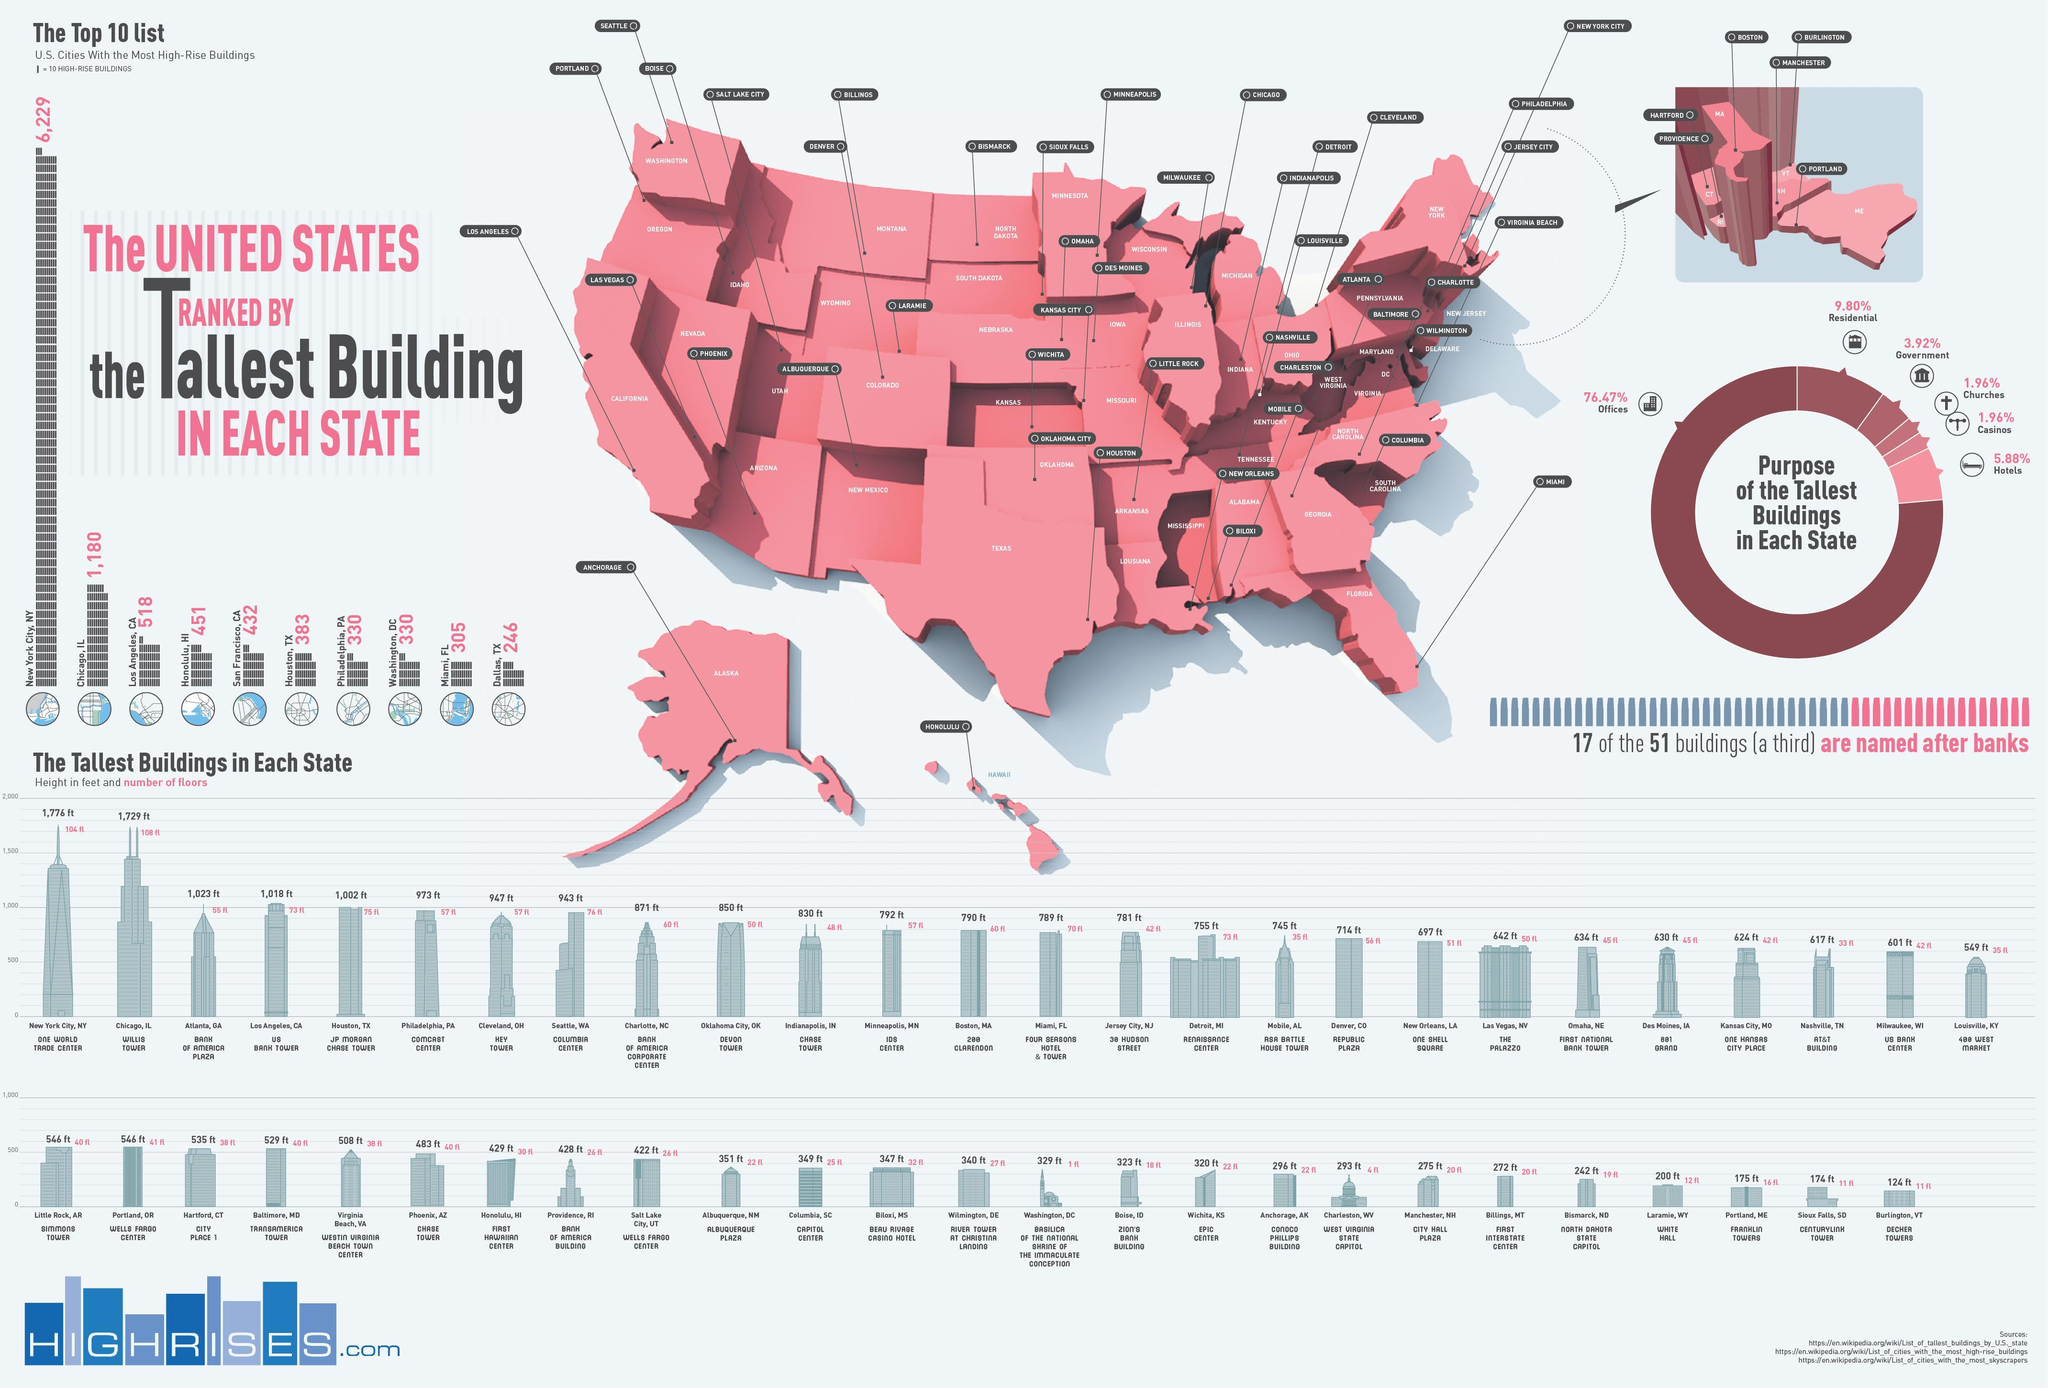Which is the tallest building in Chicago, IL?
Answer the question with a short phrase. Willis Tower What is the height of 'Republic Plaza' building located in Denver, Co? 714 ft Which is the tallest building in Detroit, MI? RENAISSANCE CENTER What percent of the tallest buildings in each state serve as hotels? 5.88% What percent of the tallest buildings in each state serve as offices? 76.47% Which is the tallest building in the New York City? ONE WORLD TRADE CENTER In which U.S city/state, Columbia Center is located? Seattle, WA What is the height of 'US Bank Tower' located in Los Angeles, CA? 1,018 ft How many floors are there in 'Willis Tower' located in Chicago? 108 fl 